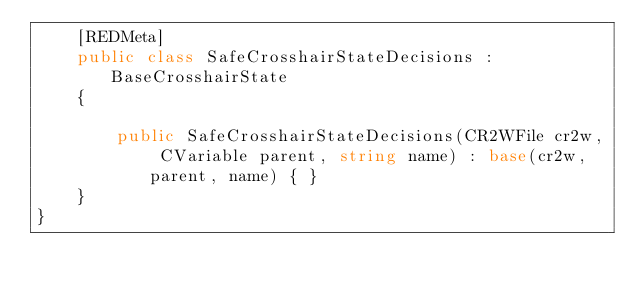<code> <loc_0><loc_0><loc_500><loc_500><_C#_>	[REDMeta]
	public class SafeCrosshairStateDecisions : BaseCrosshairState
	{

		public SafeCrosshairStateDecisions(CR2WFile cr2w, CVariable parent, string name) : base(cr2w, parent, name) { }
	}
}
</code> 